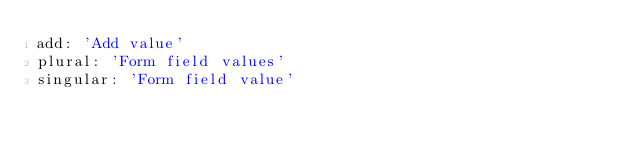<code> <loc_0><loc_0><loc_500><loc_500><_YAML_>add: 'Add value'
plural: 'Form field values'
singular: 'Form field value'
</code> 